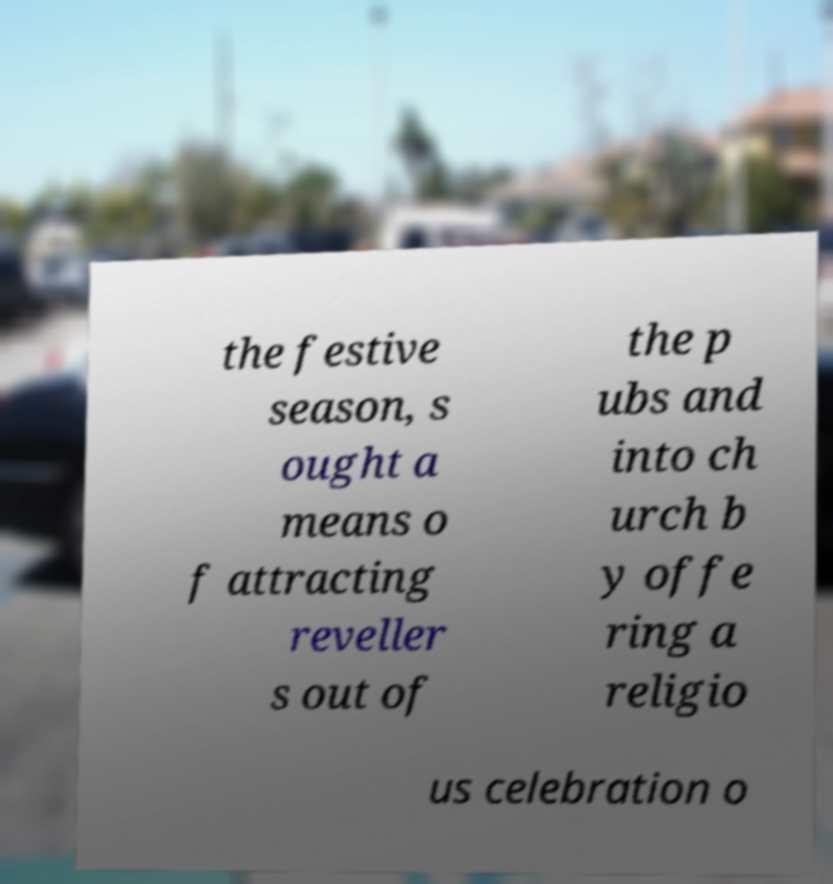For documentation purposes, I need the text within this image transcribed. Could you provide that? the festive season, s ought a means o f attracting reveller s out of the p ubs and into ch urch b y offe ring a religio us celebration o 